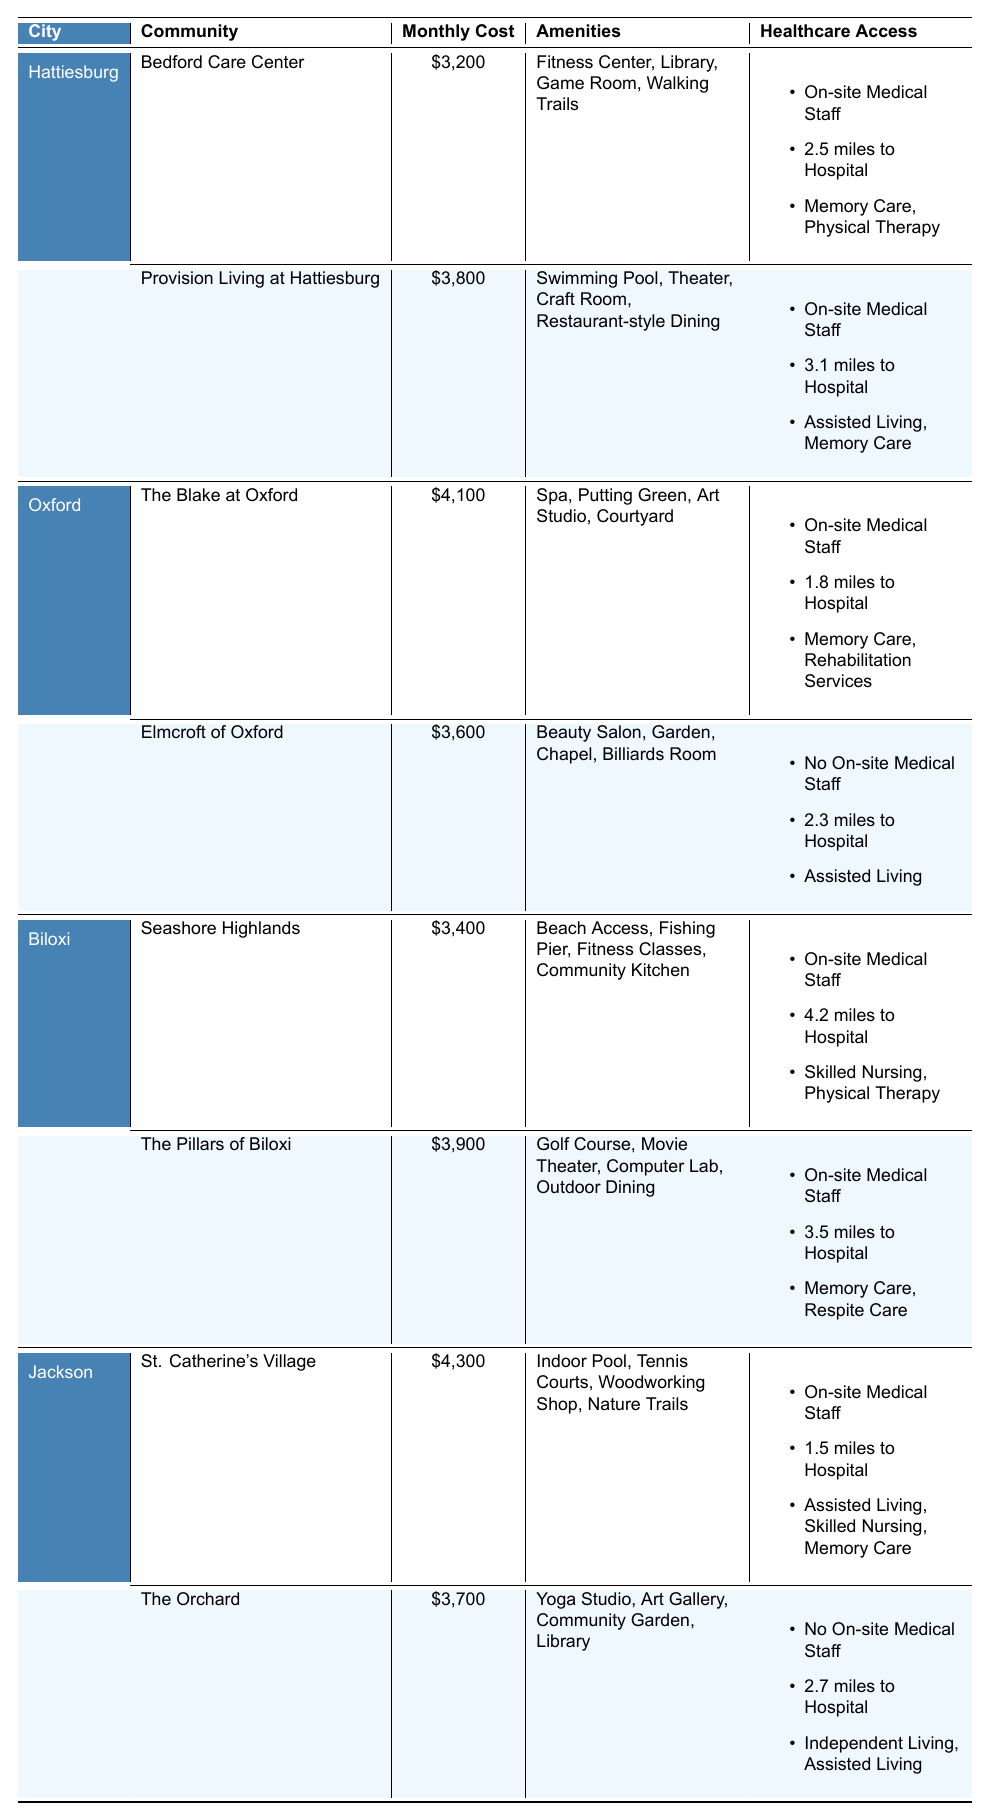What is the monthly cost of Provision Living at Hattiesburg? The table shows that the monthly cost for Provision Living at Hattiesburg is listed as $3,800.
Answer: $3,800 Which community in Hattiesburg has the lowest monthly cost? Comparing the monthly costs of Bedford Care Center ($3,200) and Provision Living at Hattiesburg ($3,800), Bedford Care Center has the lowest cost.
Answer: Bedford Care Center How many communities in Oxford have on-site medical staff? The Blake at Oxford and Elmcroft of Oxford are the two communities in Oxford. The table indicates that both offer on-site medical staff, so the total is 2.
Answer: 2 Which community offers the most specialized care options in Jackson? St. Catherine's Village offers three specialized care options (Assisted Living, Skilled Nursing, Memory Care), while The Orchard offers two (Independent Living, Assisted Living). Therefore, St. Catherine's Village has the most.
Answer: St. Catherine's Village What is the average monthly cost of communities in Biloxi? The two communities in Biloxi have costs of $3,400 and $3,900. The sum is $3,400 + $3,900 = $7,300, divided by 2 gives the average cost of $3,650.
Answer: $3,650 Do any communities in Jackson have no on-site medical staff? The table indicates that The Orchard does not have on-site medical staff, while St. Catherine's Village does. Therefore, the answer is yes.
Answer: Yes What is the distance to the nearest hospital for Elmcroft of Oxford? The table states that the distance to the nearest hospital for Elmcroft of Oxford is 2.3 miles.
Answer: 2.3 miles Which community offers a yoga studio and what is its monthly cost? The Orchard in Jackson offers a yoga studio, and its monthly cost is $3,700 as indicated in the table.
Answer: The Orchard; $3,700 How does the monthly cost of Seashore Highlands in Biloxi compare to the average cost of all communities listed? Seashore Highlands costs $3,400. The average cost of all communities can be calculated by summing all monthly costs ($3,200 + $3,800 + $4,100 + $3,600 + $3,400 + $3,900 + $4,300 + $3,700 = $26,100) and dividing by 8, which is $3,262.50. Since $3,400 is greater than $3,262.50, it costs more than average.
Answer: More than average Which retirement community across all cities has the highest monthly cost? The highest monthly cost is for St. Catherine's Village in Jackson at $4,300, as compared to others in the table.
Answer: St. Catherine's Village What specialized care options are available at the Pillars of Biloxi? The Pillars of Biloxi offers Memory Care and Respite Care as per the information given in the table.
Answer: Memory Care, Respite Care 